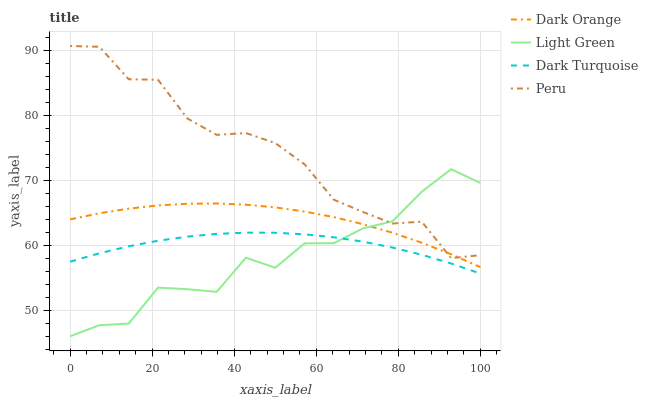Does Light Green have the minimum area under the curve?
Answer yes or no. Yes. Does Peru have the maximum area under the curve?
Answer yes or no. Yes. Does Peru have the minimum area under the curve?
Answer yes or no. No. Does Light Green have the maximum area under the curve?
Answer yes or no. No. Is Dark Turquoise the smoothest?
Answer yes or no. Yes. Is Light Green the roughest?
Answer yes or no. Yes. Is Peru the smoothest?
Answer yes or no. No. Is Peru the roughest?
Answer yes or no. No. Does Light Green have the lowest value?
Answer yes or no. Yes. Does Peru have the lowest value?
Answer yes or no. No. Does Peru have the highest value?
Answer yes or no. Yes. Does Light Green have the highest value?
Answer yes or no. No. Is Dark Turquoise less than Peru?
Answer yes or no. Yes. Is Dark Orange greater than Dark Turquoise?
Answer yes or no. Yes. Does Light Green intersect Dark Orange?
Answer yes or no. Yes. Is Light Green less than Dark Orange?
Answer yes or no. No. Is Light Green greater than Dark Orange?
Answer yes or no. No. Does Dark Turquoise intersect Peru?
Answer yes or no. No. 